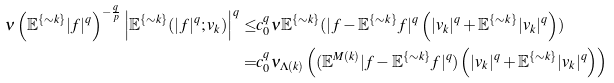<formula> <loc_0><loc_0><loc_500><loc_500>\nu \left ( \mathbb { E } ^ { \{ \sim k \} } | f | ^ { q } \right ) ^ { - \frac { q } { p } } \left | \mathbb { E } ^ { \{ \sim k \} } ( | f | ^ { q } ; v _ { k } ) \right | ^ { q } \leq & c ^ { q } _ { 0 } \nu \mathbb { E } ^ { \{ \sim k \} } ( | f - \mathbb { E } ^ { \{ \sim k \} } f | ^ { q } \left ( | v _ { k } | ^ { q } + \mathbb { E } ^ { \{ \sim k \} } | v _ { k } | ^ { q } \right ) ) \\ = & c ^ { q } _ { 0 } \nu _ { \Lambda ( k ) } \left ( ( \mathbb { E } ^ { M ( k ) } | f - \mathbb { E } ^ { \{ \sim k \} } f | ^ { q } ) \left ( | v _ { k } | ^ { q } + \mathbb { E } ^ { \{ \sim k \} } | v _ { k } | ^ { q } \right ) \right )</formula> 